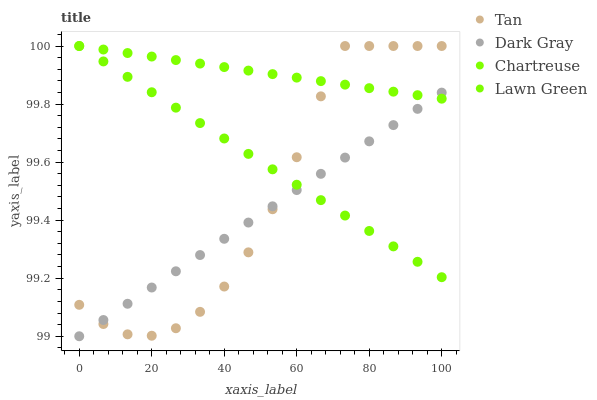Does Dark Gray have the minimum area under the curve?
Answer yes or no. Yes. Does Chartreuse have the maximum area under the curve?
Answer yes or no. Yes. Does Lawn Green have the minimum area under the curve?
Answer yes or no. No. Does Lawn Green have the maximum area under the curve?
Answer yes or no. No. Is Lawn Green the smoothest?
Answer yes or no. Yes. Is Tan the roughest?
Answer yes or no. Yes. Is Tan the smoothest?
Answer yes or no. No. Is Lawn Green the roughest?
Answer yes or no. No. Does Dark Gray have the lowest value?
Answer yes or no. Yes. Does Lawn Green have the lowest value?
Answer yes or no. No. Does Chartreuse have the highest value?
Answer yes or no. Yes. Does Tan intersect Lawn Green?
Answer yes or no. Yes. Is Tan less than Lawn Green?
Answer yes or no. No. Is Tan greater than Lawn Green?
Answer yes or no. No. 